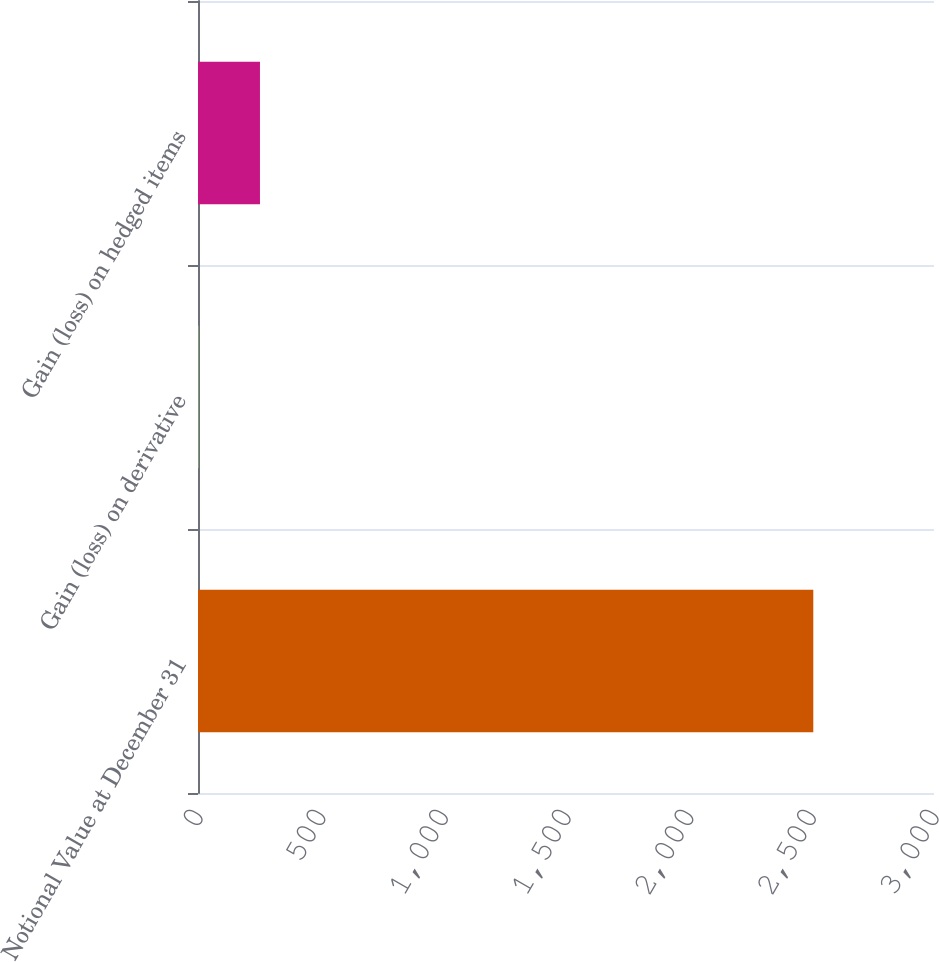Convert chart to OTSL. <chart><loc_0><loc_0><loc_500><loc_500><bar_chart><fcel>Notional Value at December 31<fcel>Gain (loss) on derivative<fcel>Gain (loss) on hedged items<nl><fcel>2508<fcel>2<fcel>252.6<nl></chart> 